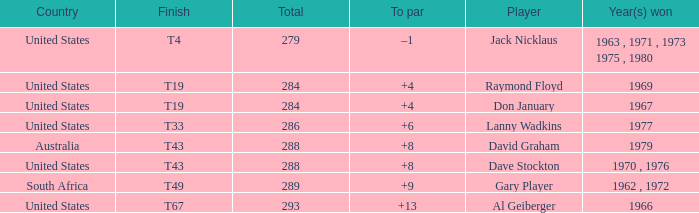What is the average total in 1969? 284.0. 